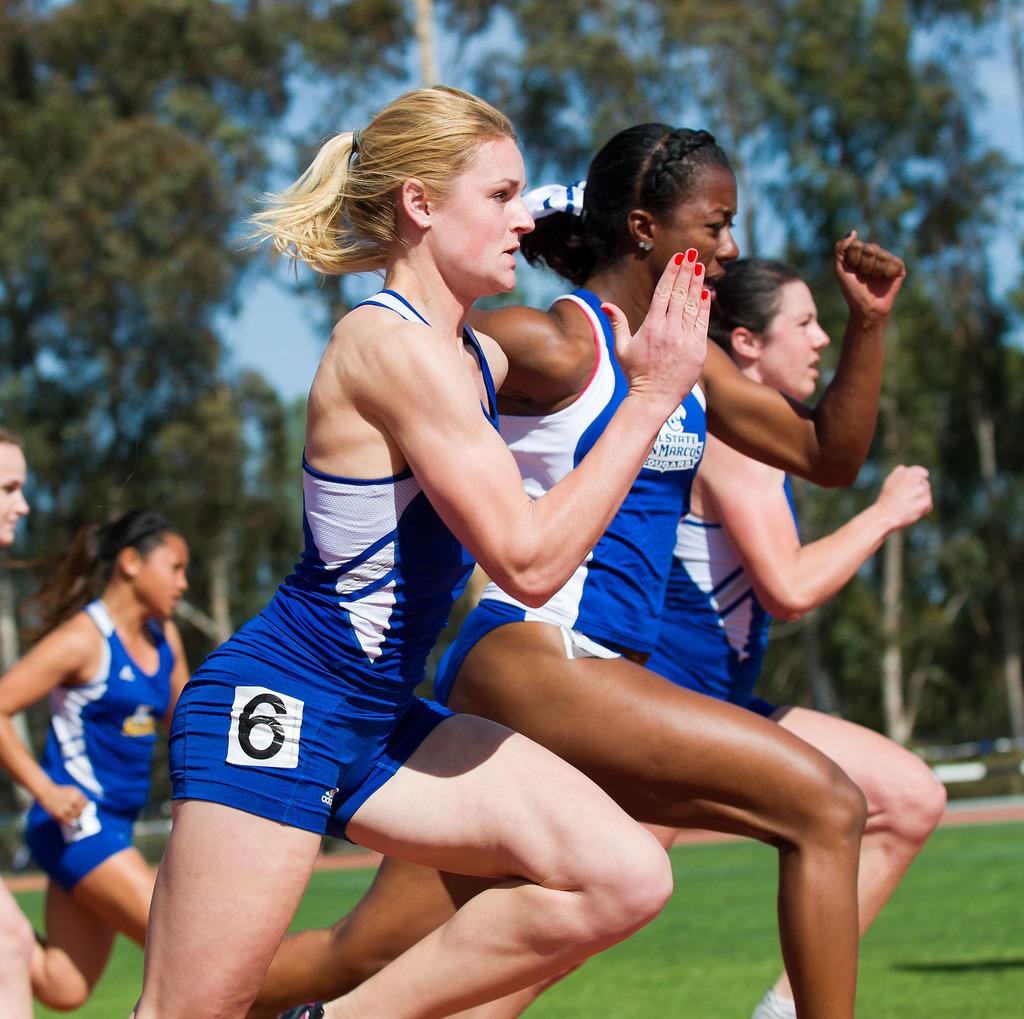What is the mascot of the school the middle racer is representing?
Provide a succinct answer. Cougars. What is the blond ladies racing number?
Keep it short and to the point. 6. 